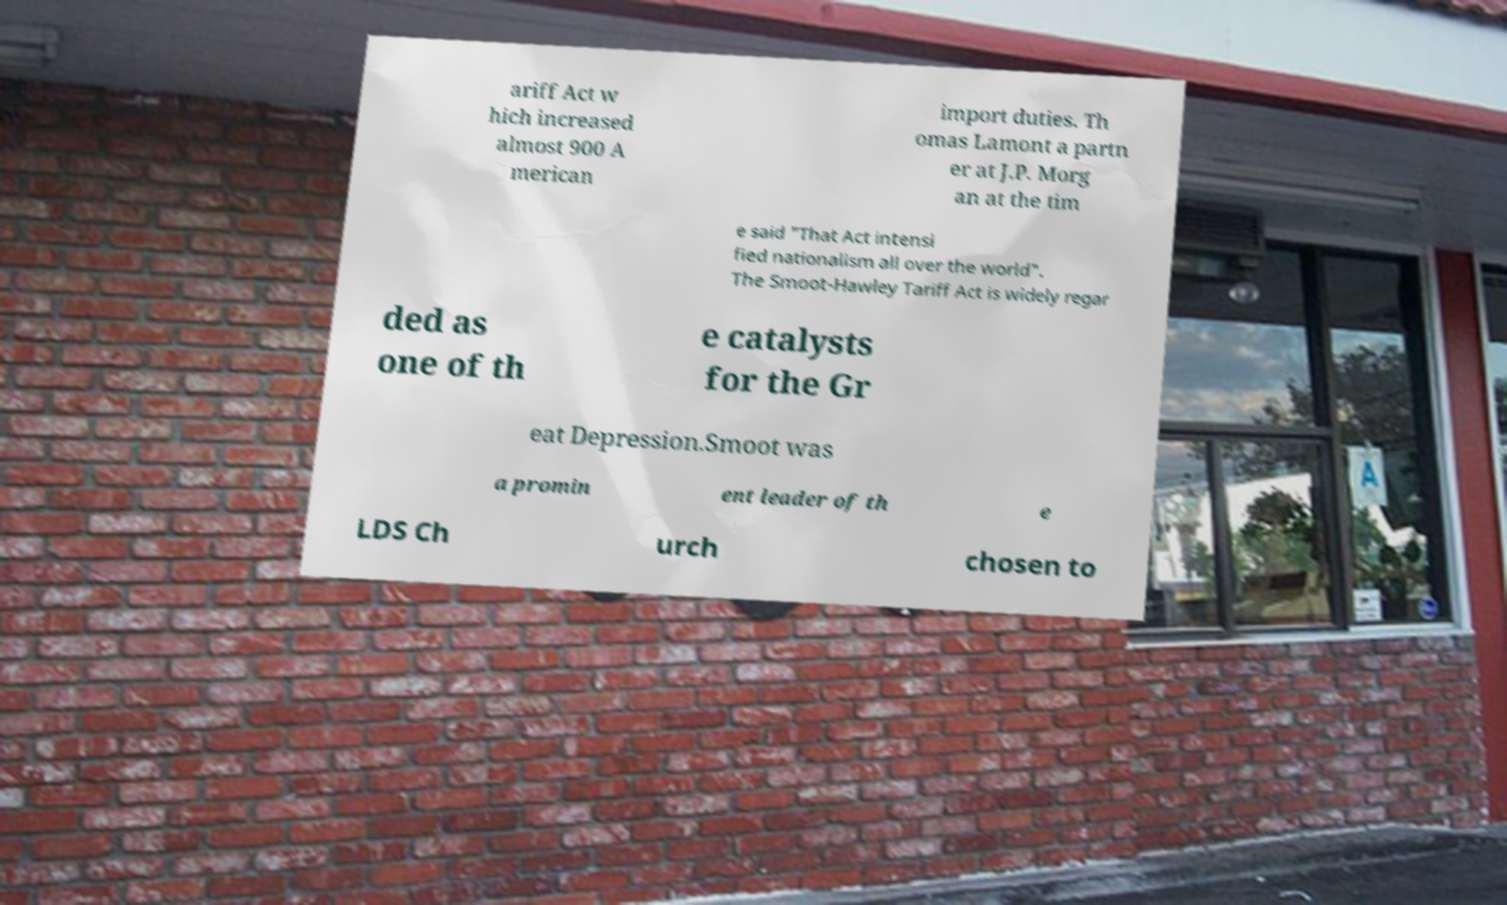Can you accurately transcribe the text from the provided image for me? ariff Act w hich increased almost 900 A merican import duties. Th omas Lamont a partn er at J.P. Morg an at the tim e said "That Act intensi fied nationalism all over the world". The Smoot-Hawley Tariff Act is widely regar ded as one of th e catalysts for the Gr eat Depression.Smoot was a promin ent leader of th e LDS Ch urch chosen to 